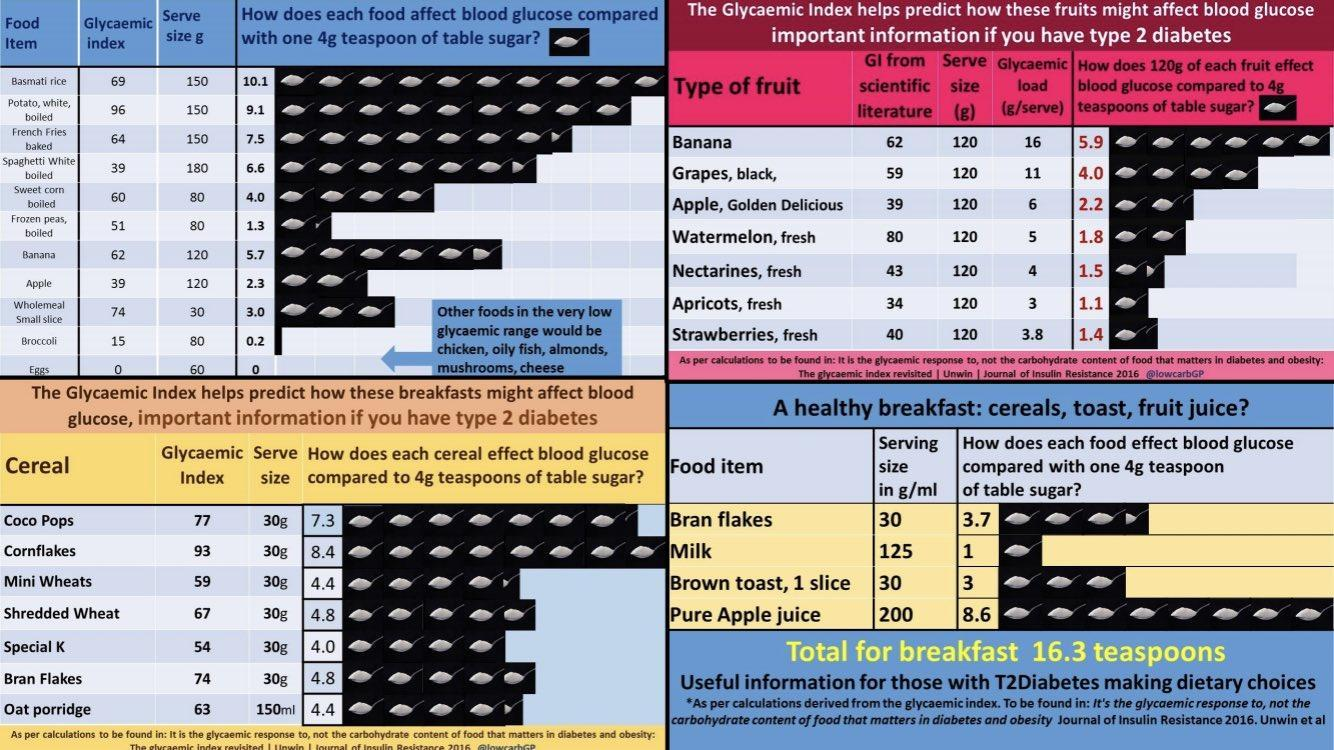What is the glycemic index of banana per 120g serve size?
Answer the question with a short phrase. 62 What is the glycemic index of eggs per 60g serve size? 0 